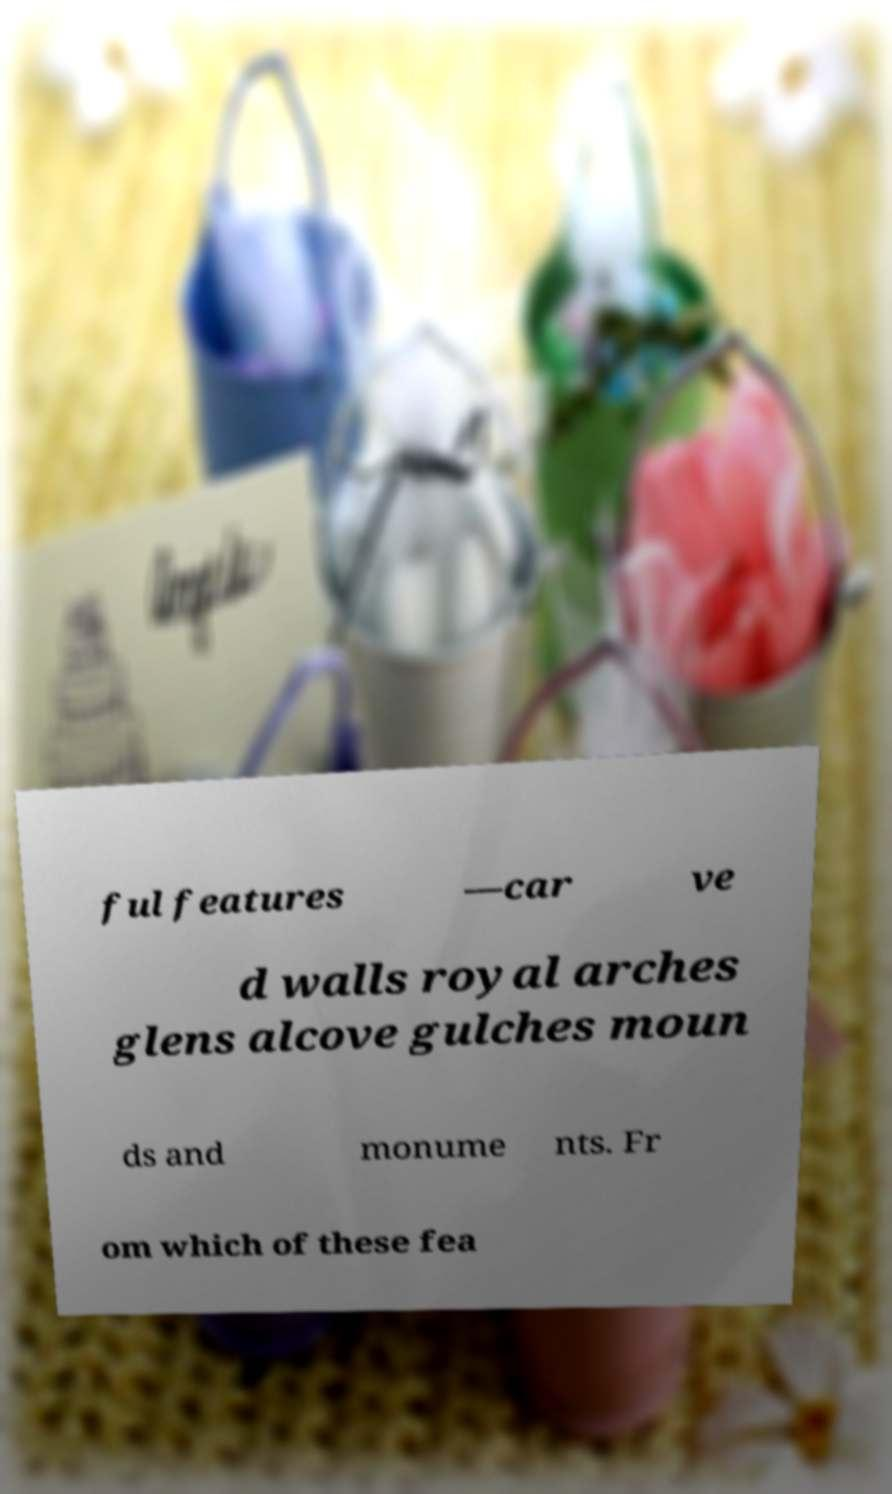Can you accurately transcribe the text from the provided image for me? ful features —car ve d walls royal arches glens alcove gulches moun ds and monume nts. Fr om which of these fea 